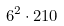<formula> <loc_0><loc_0><loc_500><loc_500>6 ^ { 2 } \cdot 2 1 0</formula> 